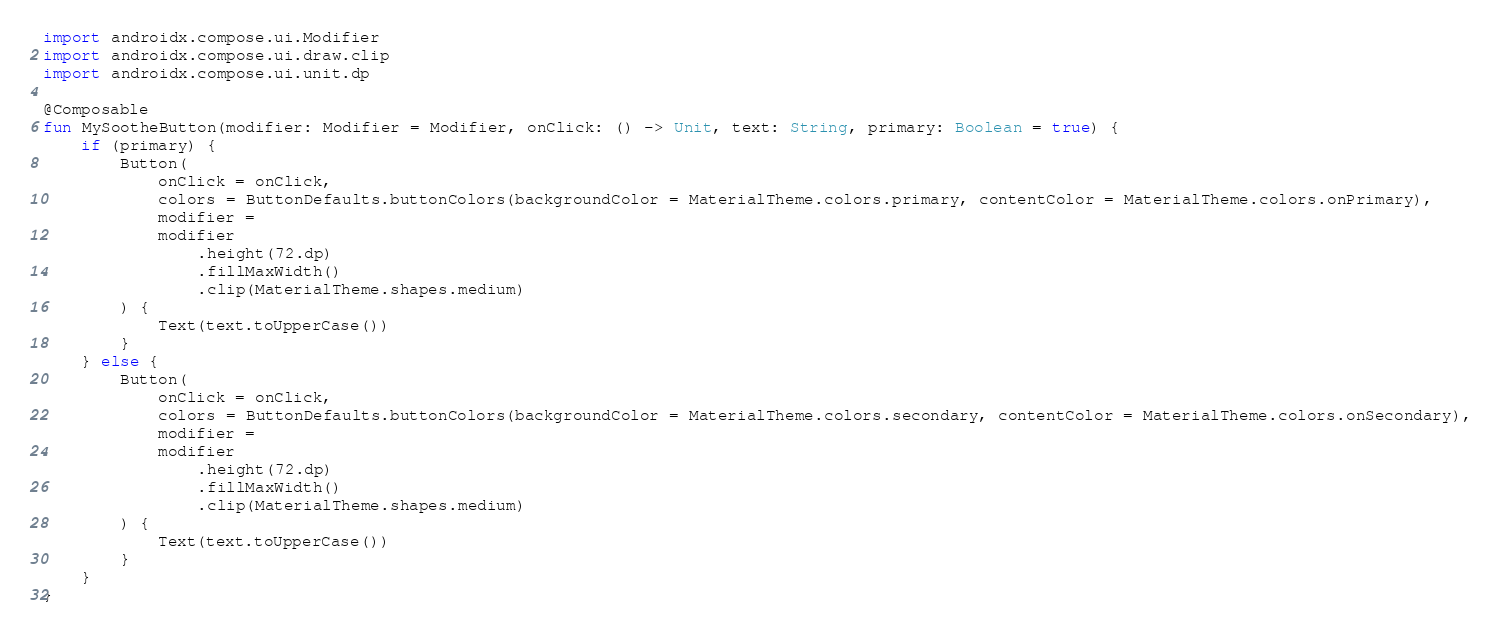Convert code to text. <code><loc_0><loc_0><loc_500><loc_500><_Kotlin_>import androidx.compose.ui.Modifier
import androidx.compose.ui.draw.clip
import androidx.compose.ui.unit.dp

@Composable
fun MySootheButton(modifier: Modifier = Modifier, onClick: () -> Unit, text: String, primary: Boolean = true) {
    if (primary) {
        Button(
            onClick = onClick,
            colors = ButtonDefaults.buttonColors(backgroundColor = MaterialTheme.colors.primary, contentColor = MaterialTheme.colors.onPrimary),
            modifier =
            modifier
                .height(72.dp)
                .fillMaxWidth()
                .clip(MaterialTheme.shapes.medium)
        ) {
            Text(text.toUpperCase())
        }
    } else {
        Button(
            onClick = onClick,
            colors = ButtonDefaults.buttonColors(backgroundColor = MaterialTheme.colors.secondary, contentColor = MaterialTheme.colors.onSecondary),
            modifier =
            modifier
                .height(72.dp)
                .fillMaxWidth()
                .clip(MaterialTheme.shapes.medium)
        ) {
            Text(text.toUpperCase())
        }
    }
}</code> 